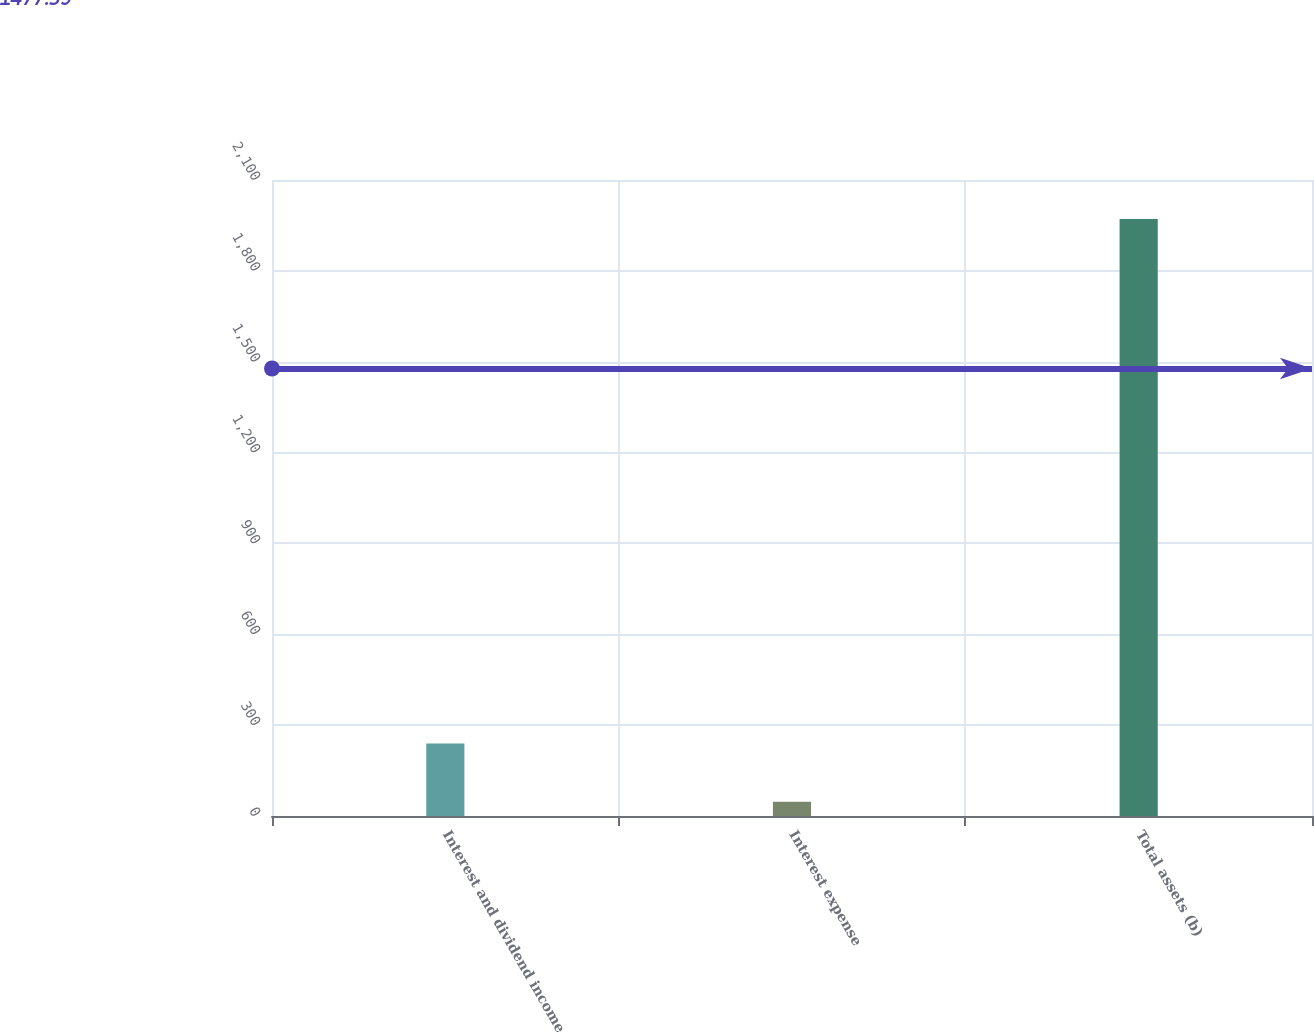<chart> <loc_0><loc_0><loc_500><loc_500><bar_chart><fcel>Interest and dividend income<fcel>Interest expense<fcel>Total assets (b)<nl><fcel>239.4<fcel>47<fcel>1971<nl></chart> 